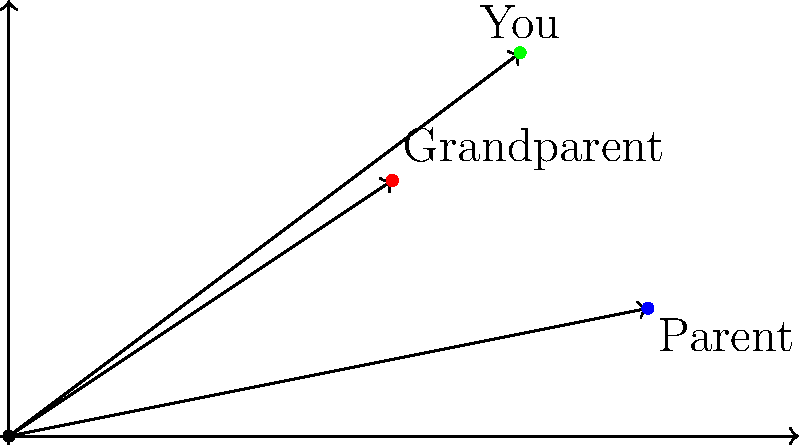In documenting your family's history, you represent the life journeys of your grandparent, parent, and yourself as vectors from the origin. If your grandparent's journey is represented by vector $\vec{a} = 3\hat{i} + 2\hat{j}$, your parent's by $\vec{b} = 5\hat{i} + \hat{j}$, and yours by $\vec{c} = 4\hat{i} + 3\hat{j}$, at what point do all three journeys intersect? To find the intersection point of all three vectors, we need to determine if there's a common point where all three vectors meet. Let's approach this step-by-step:

1. First, we need to understand that vectors originating from the same point (in this case, the origin) can only intersect at their endpoints if they are identical.

2. Looking at the given vectors:
   $\vec{a} = 3\hat{i} + 2\hat{j}$
   $\vec{b} = 5\hat{i} + \hat{j}$
   $\vec{c} = 4\hat{i} + 3\hat{j}$

3. We can see that all three vectors have different components, which means they don't share a common endpoint.

4. In vector analysis, vectors originating from the same point can only intersect at the origin (0,0), which is their starting point.

5. This makes sense in the context of family history as well. The origin represents the common starting point of all family journeys, symbolizing shared roots or the beginning of the family line being documented.

Therefore, the only point where all three "journey" vectors intersect is at their common origin, the point (0,0).
Answer: (0,0) 